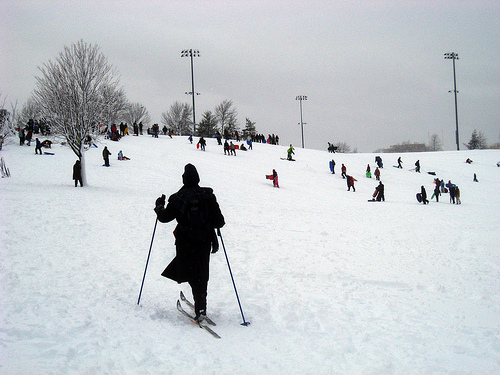Please provide a short description for this region: [0.26, 0.51, 0.34, 0.76]. A person gripping a ski pole in their hand, essential for balance and movement on the snow. 